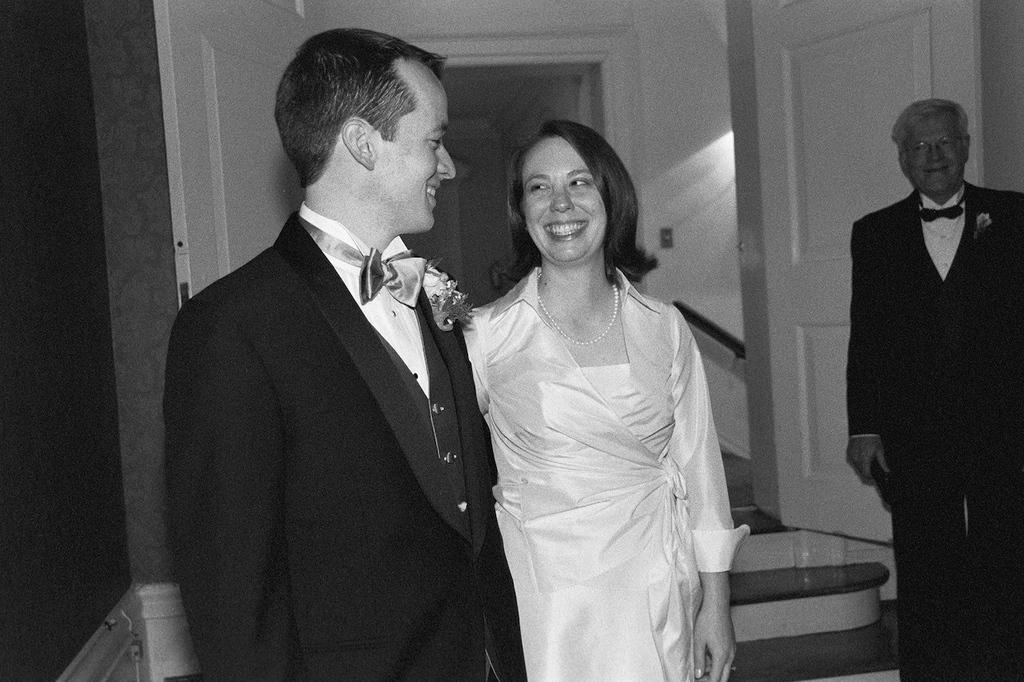Describe this image in one or two sentences. In this picture we can see three people and they are smiling and in the background we can see the wall and doors. 